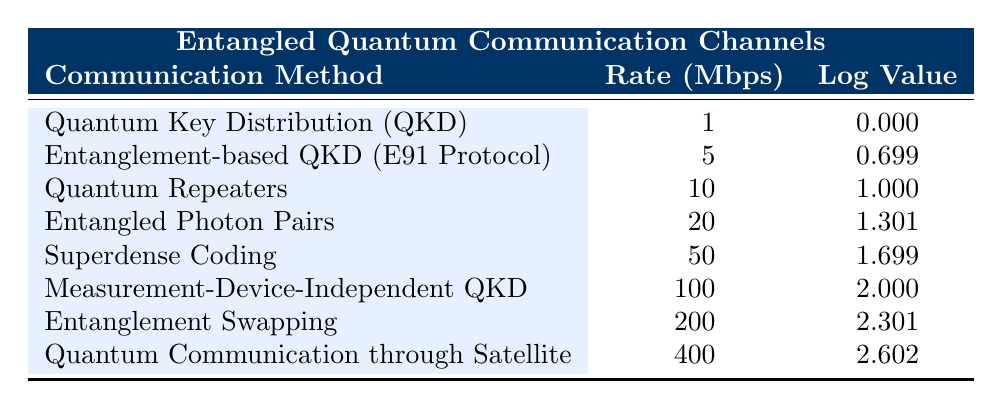What is the transmission rate of Entangled Photon Pairs? According to the table, the transmission rate for Entangled Photon Pairs is listed under the corresponding communication method. It directly shows a value of 20 Mbps.
Answer: 20 Mbps Which communication method has the highest logarithmic value? By examining the logarithmic values in the table, Quantum Communication through Satellite shows the highest value of 2.602, making it the communication method with the highest logarithmic value.
Answer: Quantum Communication through Satellite What is the difference in transmission rate between Quantum Key Distribution and Measurement-Device-Independent QKD? The transmission rate for Quantum Key Distribution is 1 Mbps, and for Measurement-Device-Independent QKD, it is 100 Mbps. The difference is calculated as 100 - 1 = 99 Mbps.
Answer: 99 Mbps Is the logarithmic value of Superdense Coding greater than that of Quantum Repeaters? The logarithmic value for Superdense Coding is 1.699, while for Quantum Repeaters, it is 1. The value for Superdense Coding is indeed greater. Thus, the answer is true.
Answer: Yes What is the average transmission rate of the communication methods listed in the table? The transmission rates are 1, 5, 10, 20, 50, 100, 200, and 400 Mbps. Adding these up gives a sum of 786 Mbps. There are 8 methods, so the average is 786/8 = 98.25 Mbps.
Answer: 98.25 Mbps How many communication methods have a transmission rate greater than 50 Mbps? Reviewing the transmission rates, those greater than 50 Mbps are Measurement-Device-Independent QKD (100 Mbps), Entanglement Swapping (200 Mbps), and Quantum Communication through Satellite (400 Mbps). That totals 3 methods.
Answer: 3 methods Which communication method has a logarithmic value closest to 1.5? Looking at the logarithmic values, Superdense Coding has a value of 1.699 which is closest to 1.5 when compared to others.
Answer: Superdense Coding If you were to rank the communication methods by their logarithmic values from highest to lowest, which method would rank 3rd? The logarithmic values in descending order are: Quantum Communication through Satellite (2.602), Entanglement Swapping (2.301), and Measurement-Device-Independent QKD (2.000), making the 3rd ranked method Measurement-Device-Independent QKD.
Answer: Measurement-Device-Independent QKD 